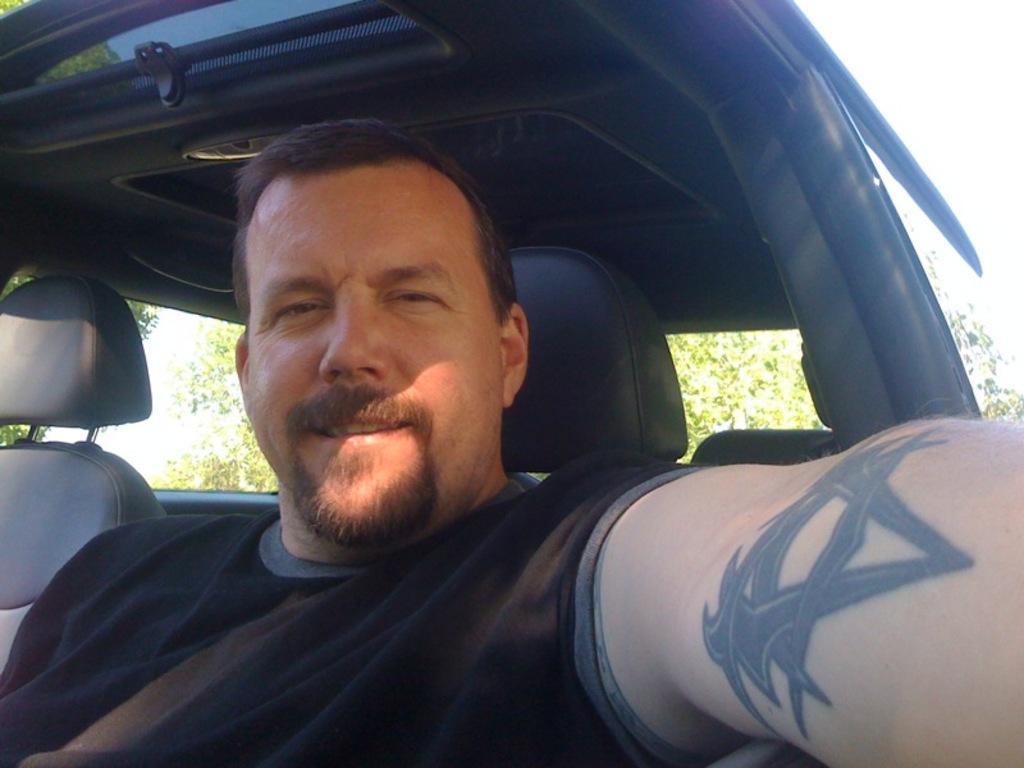Could you give a brief overview of what you see in this image? In this image we can see a man sitting in the car and trees in the background. 